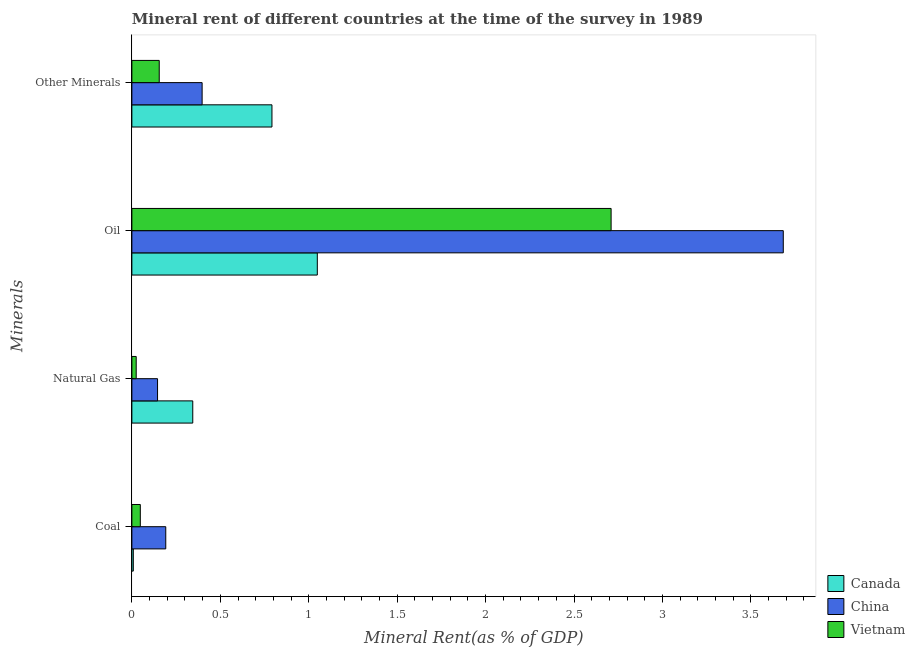How many groups of bars are there?
Keep it short and to the point. 4. Are the number of bars per tick equal to the number of legend labels?
Give a very brief answer. Yes. What is the label of the 1st group of bars from the top?
Provide a succinct answer. Other Minerals. What is the  rent of other minerals in Canada?
Your answer should be compact. 0.79. Across all countries, what is the maximum coal rent?
Provide a short and direct response. 0.19. Across all countries, what is the minimum  rent of other minerals?
Your answer should be very brief. 0.15. In which country was the oil rent minimum?
Ensure brevity in your answer.  Canada. What is the total natural gas rent in the graph?
Give a very brief answer. 0.51. What is the difference between the natural gas rent in China and that in Canada?
Your answer should be compact. -0.2. What is the difference between the coal rent in Vietnam and the oil rent in Canada?
Provide a short and direct response. -1. What is the average coal rent per country?
Provide a short and direct response. 0.08. What is the difference between the  rent of other minerals and natural gas rent in China?
Your answer should be very brief. 0.25. In how many countries, is the  rent of other minerals greater than 2.6 %?
Offer a very short reply. 0. What is the ratio of the coal rent in Canada to that in Vietnam?
Your response must be concise. 0.17. Is the natural gas rent in Canada less than that in Vietnam?
Provide a short and direct response. No. Is the difference between the natural gas rent in Canada and China greater than the difference between the  rent of other minerals in Canada and China?
Offer a very short reply. No. What is the difference between the highest and the second highest oil rent?
Your answer should be compact. 0.97. What is the difference between the highest and the lowest natural gas rent?
Your response must be concise. 0.32. Is it the case that in every country, the sum of the coal rent and natural gas rent is greater than the oil rent?
Offer a terse response. No. How many bars are there?
Provide a short and direct response. 12. Are all the bars in the graph horizontal?
Ensure brevity in your answer.  Yes. What is the difference between two consecutive major ticks on the X-axis?
Provide a short and direct response. 0.5. What is the title of the graph?
Provide a short and direct response. Mineral rent of different countries at the time of the survey in 1989. Does "Ukraine" appear as one of the legend labels in the graph?
Your answer should be compact. No. What is the label or title of the X-axis?
Your response must be concise. Mineral Rent(as % of GDP). What is the label or title of the Y-axis?
Your answer should be very brief. Minerals. What is the Mineral Rent(as % of GDP) in Canada in Coal?
Ensure brevity in your answer.  0.01. What is the Mineral Rent(as % of GDP) of China in Coal?
Provide a short and direct response. 0.19. What is the Mineral Rent(as % of GDP) in Vietnam in Coal?
Your response must be concise. 0.05. What is the Mineral Rent(as % of GDP) in Canada in Natural Gas?
Provide a short and direct response. 0.34. What is the Mineral Rent(as % of GDP) of China in Natural Gas?
Your answer should be compact. 0.15. What is the Mineral Rent(as % of GDP) in Vietnam in Natural Gas?
Provide a succinct answer. 0.02. What is the Mineral Rent(as % of GDP) of Canada in Oil?
Your response must be concise. 1.05. What is the Mineral Rent(as % of GDP) of China in Oil?
Your response must be concise. 3.68. What is the Mineral Rent(as % of GDP) of Vietnam in Oil?
Provide a succinct answer. 2.71. What is the Mineral Rent(as % of GDP) of Canada in Other Minerals?
Offer a very short reply. 0.79. What is the Mineral Rent(as % of GDP) of China in Other Minerals?
Offer a very short reply. 0.4. What is the Mineral Rent(as % of GDP) in Vietnam in Other Minerals?
Your answer should be compact. 0.15. Across all Minerals, what is the maximum Mineral Rent(as % of GDP) in Canada?
Your answer should be compact. 1.05. Across all Minerals, what is the maximum Mineral Rent(as % of GDP) of China?
Keep it short and to the point. 3.68. Across all Minerals, what is the maximum Mineral Rent(as % of GDP) of Vietnam?
Keep it short and to the point. 2.71. Across all Minerals, what is the minimum Mineral Rent(as % of GDP) in Canada?
Make the answer very short. 0.01. Across all Minerals, what is the minimum Mineral Rent(as % of GDP) in China?
Offer a very short reply. 0.15. Across all Minerals, what is the minimum Mineral Rent(as % of GDP) in Vietnam?
Provide a short and direct response. 0.02. What is the total Mineral Rent(as % of GDP) of Canada in the graph?
Provide a succinct answer. 2.19. What is the total Mineral Rent(as % of GDP) of China in the graph?
Make the answer very short. 4.42. What is the total Mineral Rent(as % of GDP) of Vietnam in the graph?
Your response must be concise. 2.94. What is the difference between the Mineral Rent(as % of GDP) in Canada in Coal and that in Natural Gas?
Your response must be concise. -0.34. What is the difference between the Mineral Rent(as % of GDP) of China in Coal and that in Natural Gas?
Keep it short and to the point. 0.05. What is the difference between the Mineral Rent(as % of GDP) of Vietnam in Coal and that in Natural Gas?
Your answer should be very brief. 0.02. What is the difference between the Mineral Rent(as % of GDP) of Canada in Coal and that in Oil?
Keep it short and to the point. -1.04. What is the difference between the Mineral Rent(as % of GDP) of China in Coal and that in Oil?
Your response must be concise. -3.49. What is the difference between the Mineral Rent(as % of GDP) of Vietnam in Coal and that in Oil?
Provide a short and direct response. -2.66. What is the difference between the Mineral Rent(as % of GDP) of Canada in Coal and that in Other Minerals?
Offer a very short reply. -0.78. What is the difference between the Mineral Rent(as % of GDP) of China in Coal and that in Other Minerals?
Provide a succinct answer. -0.21. What is the difference between the Mineral Rent(as % of GDP) in Vietnam in Coal and that in Other Minerals?
Give a very brief answer. -0.11. What is the difference between the Mineral Rent(as % of GDP) in Canada in Natural Gas and that in Oil?
Give a very brief answer. -0.7. What is the difference between the Mineral Rent(as % of GDP) in China in Natural Gas and that in Oil?
Your answer should be very brief. -3.54. What is the difference between the Mineral Rent(as % of GDP) in Vietnam in Natural Gas and that in Oil?
Your answer should be compact. -2.69. What is the difference between the Mineral Rent(as % of GDP) in Canada in Natural Gas and that in Other Minerals?
Your answer should be compact. -0.45. What is the difference between the Mineral Rent(as % of GDP) of China in Natural Gas and that in Other Minerals?
Provide a short and direct response. -0.25. What is the difference between the Mineral Rent(as % of GDP) in Vietnam in Natural Gas and that in Other Minerals?
Provide a short and direct response. -0.13. What is the difference between the Mineral Rent(as % of GDP) of Canada in Oil and that in Other Minerals?
Make the answer very short. 0.26. What is the difference between the Mineral Rent(as % of GDP) of China in Oil and that in Other Minerals?
Provide a short and direct response. 3.29. What is the difference between the Mineral Rent(as % of GDP) of Vietnam in Oil and that in Other Minerals?
Ensure brevity in your answer.  2.55. What is the difference between the Mineral Rent(as % of GDP) of Canada in Coal and the Mineral Rent(as % of GDP) of China in Natural Gas?
Make the answer very short. -0.14. What is the difference between the Mineral Rent(as % of GDP) of Canada in Coal and the Mineral Rent(as % of GDP) of Vietnam in Natural Gas?
Provide a succinct answer. -0.02. What is the difference between the Mineral Rent(as % of GDP) of China in Coal and the Mineral Rent(as % of GDP) of Vietnam in Natural Gas?
Your answer should be compact. 0.17. What is the difference between the Mineral Rent(as % of GDP) of Canada in Coal and the Mineral Rent(as % of GDP) of China in Oil?
Keep it short and to the point. -3.67. What is the difference between the Mineral Rent(as % of GDP) of Canada in Coal and the Mineral Rent(as % of GDP) of Vietnam in Oil?
Your answer should be compact. -2.7. What is the difference between the Mineral Rent(as % of GDP) in China in Coal and the Mineral Rent(as % of GDP) in Vietnam in Oil?
Give a very brief answer. -2.52. What is the difference between the Mineral Rent(as % of GDP) in Canada in Coal and the Mineral Rent(as % of GDP) in China in Other Minerals?
Make the answer very short. -0.39. What is the difference between the Mineral Rent(as % of GDP) of Canada in Coal and the Mineral Rent(as % of GDP) of Vietnam in Other Minerals?
Make the answer very short. -0.15. What is the difference between the Mineral Rent(as % of GDP) in China in Coal and the Mineral Rent(as % of GDP) in Vietnam in Other Minerals?
Your response must be concise. 0.04. What is the difference between the Mineral Rent(as % of GDP) of Canada in Natural Gas and the Mineral Rent(as % of GDP) of China in Oil?
Your answer should be compact. -3.34. What is the difference between the Mineral Rent(as % of GDP) in Canada in Natural Gas and the Mineral Rent(as % of GDP) in Vietnam in Oil?
Your response must be concise. -2.37. What is the difference between the Mineral Rent(as % of GDP) in China in Natural Gas and the Mineral Rent(as % of GDP) in Vietnam in Oil?
Ensure brevity in your answer.  -2.56. What is the difference between the Mineral Rent(as % of GDP) of Canada in Natural Gas and the Mineral Rent(as % of GDP) of China in Other Minerals?
Make the answer very short. -0.05. What is the difference between the Mineral Rent(as % of GDP) of Canada in Natural Gas and the Mineral Rent(as % of GDP) of Vietnam in Other Minerals?
Keep it short and to the point. 0.19. What is the difference between the Mineral Rent(as % of GDP) of China in Natural Gas and the Mineral Rent(as % of GDP) of Vietnam in Other Minerals?
Your answer should be very brief. -0.01. What is the difference between the Mineral Rent(as % of GDP) in Canada in Oil and the Mineral Rent(as % of GDP) in China in Other Minerals?
Give a very brief answer. 0.65. What is the difference between the Mineral Rent(as % of GDP) in Canada in Oil and the Mineral Rent(as % of GDP) in Vietnam in Other Minerals?
Your answer should be very brief. 0.89. What is the difference between the Mineral Rent(as % of GDP) of China in Oil and the Mineral Rent(as % of GDP) of Vietnam in Other Minerals?
Your answer should be very brief. 3.53. What is the average Mineral Rent(as % of GDP) of Canada per Minerals?
Offer a terse response. 0.55. What is the average Mineral Rent(as % of GDP) of China per Minerals?
Make the answer very short. 1.1. What is the average Mineral Rent(as % of GDP) of Vietnam per Minerals?
Give a very brief answer. 0.73. What is the difference between the Mineral Rent(as % of GDP) in Canada and Mineral Rent(as % of GDP) in China in Coal?
Make the answer very short. -0.18. What is the difference between the Mineral Rent(as % of GDP) in Canada and Mineral Rent(as % of GDP) in Vietnam in Coal?
Offer a very short reply. -0.04. What is the difference between the Mineral Rent(as % of GDP) in China and Mineral Rent(as % of GDP) in Vietnam in Coal?
Give a very brief answer. 0.14. What is the difference between the Mineral Rent(as % of GDP) of Canada and Mineral Rent(as % of GDP) of China in Natural Gas?
Your answer should be very brief. 0.2. What is the difference between the Mineral Rent(as % of GDP) in Canada and Mineral Rent(as % of GDP) in Vietnam in Natural Gas?
Make the answer very short. 0.32. What is the difference between the Mineral Rent(as % of GDP) of China and Mineral Rent(as % of GDP) of Vietnam in Natural Gas?
Your response must be concise. 0.12. What is the difference between the Mineral Rent(as % of GDP) of Canada and Mineral Rent(as % of GDP) of China in Oil?
Your answer should be very brief. -2.63. What is the difference between the Mineral Rent(as % of GDP) of Canada and Mineral Rent(as % of GDP) of Vietnam in Oil?
Provide a succinct answer. -1.66. What is the difference between the Mineral Rent(as % of GDP) of China and Mineral Rent(as % of GDP) of Vietnam in Oil?
Give a very brief answer. 0.97. What is the difference between the Mineral Rent(as % of GDP) of Canada and Mineral Rent(as % of GDP) of China in Other Minerals?
Your answer should be compact. 0.39. What is the difference between the Mineral Rent(as % of GDP) of Canada and Mineral Rent(as % of GDP) of Vietnam in Other Minerals?
Your response must be concise. 0.64. What is the difference between the Mineral Rent(as % of GDP) of China and Mineral Rent(as % of GDP) of Vietnam in Other Minerals?
Provide a succinct answer. 0.24. What is the ratio of the Mineral Rent(as % of GDP) in Canada in Coal to that in Natural Gas?
Make the answer very short. 0.02. What is the ratio of the Mineral Rent(as % of GDP) in China in Coal to that in Natural Gas?
Make the answer very short. 1.32. What is the ratio of the Mineral Rent(as % of GDP) of Vietnam in Coal to that in Natural Gas?
Offer a terse response. 1.95. What is the ratio of the Mineral Rent(as % of GDP) of Canada in Coal to that in Oil?
Give a very brief answer. 0.01. What is the ratio of the Mineral Rent(as % of GDP) in China in Coal to that in Oil?
Offer a terse response. 0.05. What is the ratio of the Mineral Rent(as % of GDP) of Vietnam in Coal to that in Oil?
Offer a terse response. 0.02. What is the ratio of the Mineral Rent(as % of GDP) of Canada in Coal to that in Other Minerals?
Make the answer very short. 0.01. What is the ratio of the Mineral Rent(as % of GDP) in China in Coal to that in Other Minerals?
Your answer should be compact. 0.48. What is the ratio of the Mineral Rent(as % of GDP) of Vietnam in Coal to that in Other Minerals?
Your answer should be compact. 0.31. What is the ratio of the Mineral Rent(as % of GDP) of Canada in Natural Gas to that in Oil?
Ensure brevity in your answer.  0.33. What is the ratio of the Mineral Rent(as % of GDP) of China in Natural Gas to that in Oil?
Give a very brief answer. 0.04. What is the ratio of the Mineral Rent(as % of GDP) of Vietnam in Natural Gas to that in Oil?
Your response must be concise. 0.01. What is the ratio of the Mineral Rent(as % of GDP) of Canada in Natural Gas to that in Other Minerals?
Make the answer very short. 0.43. What is the ratio of the Mineral Rent(as % of GDP) in China in Natural Gas to that in Other Minerals?
Your answer should be compact. 0.37. What is the ratio of the Mineral Rent(as % of GDP) of Vietnam in Natural Gas to that in Other Minerals?
Make the answer very short. 0.16. What is the ratio of the Mineral Rent(as % of GDP) of Canada in Oil to that in Other Minerals?
Provide a short and direct response. 1.32. What is the ratio of the Mineral Rent(as % of GDP) in China in Oil to that in Other Minerals?
Offer a terse response. 9.27. What is the ratio of the Mineral Rent(as % of GDP) in Vietnam in Oil to that in Other Minerals?
Offer a very short reply. 17.52. What is the difference between the highest and the second highest Mineral Rent(as % of GDP) in Canada?
Keep it short and to the point. 0.26. What is the difference between the highest and the second highest Mineral Rent(as % of GDP) of China?
Offer a terse response. 3.29. What is the difference between the highest and the second highest Mineral Rent(as % of GDP) of Vietnam?
Offer a terse response. 2.55. What is the difference between the highest and the lowest Mineral Rent(as % of GDP) in Canada?
Your response must be concise. 1.04. What is the difference between the highest and the lowest Mineral Rent(as % of GDP) of China?
Give a very brief answer. 3.54. What is the difference between the highest and the lowest Mineral Rent(as % of GDP) in Vietnam?
Offer a terse response. 2.69. 